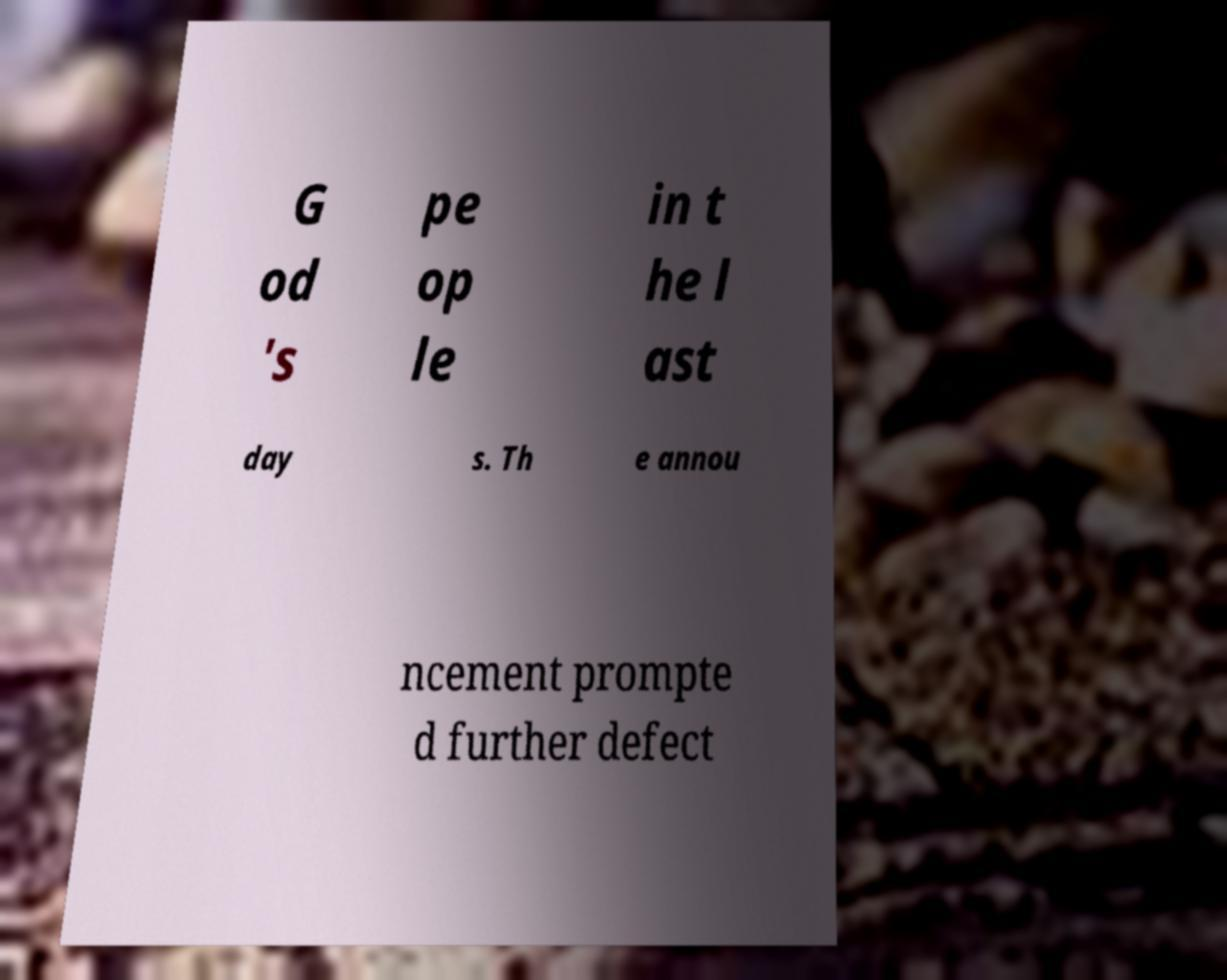I need the written content from this picture converted into text. Can you do that? G od 's pe op le in t he l ast day s. Th e annou ncement prompte d further defect 